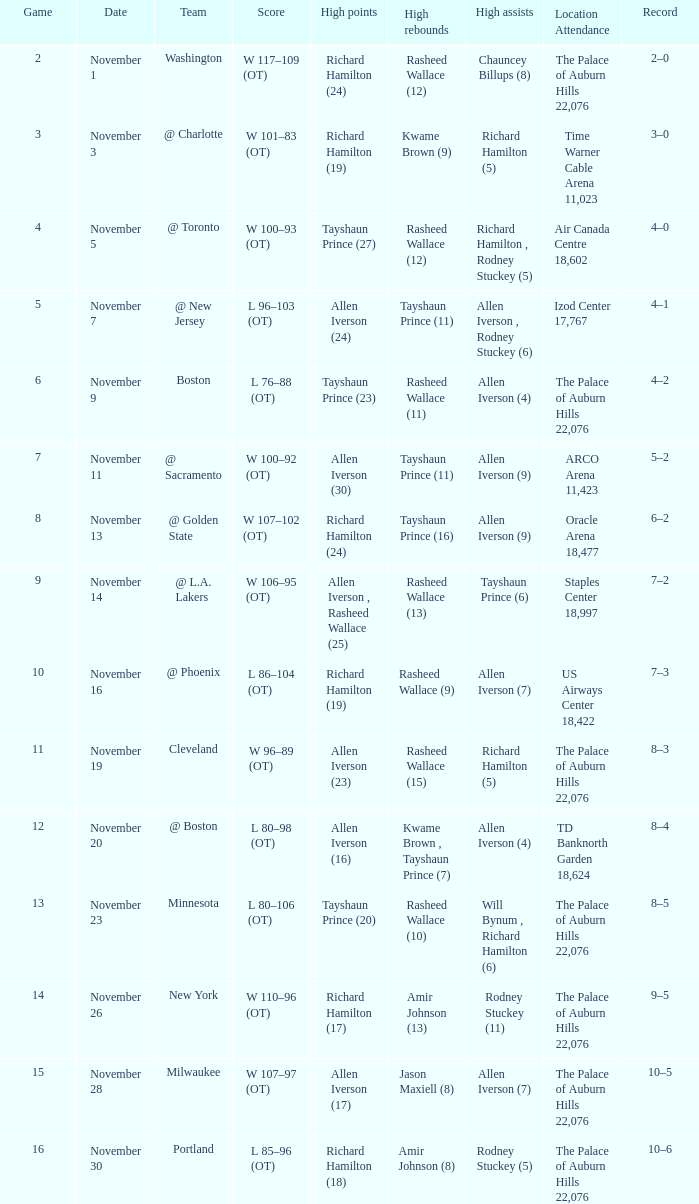What is High Points, when Game is "5"? Allen Iverson (24). 